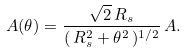<formula> <loc_0><loc_0><loc_500><loc_500>A ( \theta ) = \frac { \sqrt { 2 } \, R _ { s } } { ( \, R _ { s } ^ { 2 } + \theta ^ { 2 } \, ) ^ { 1 / 2 } } \, A .</formula> 